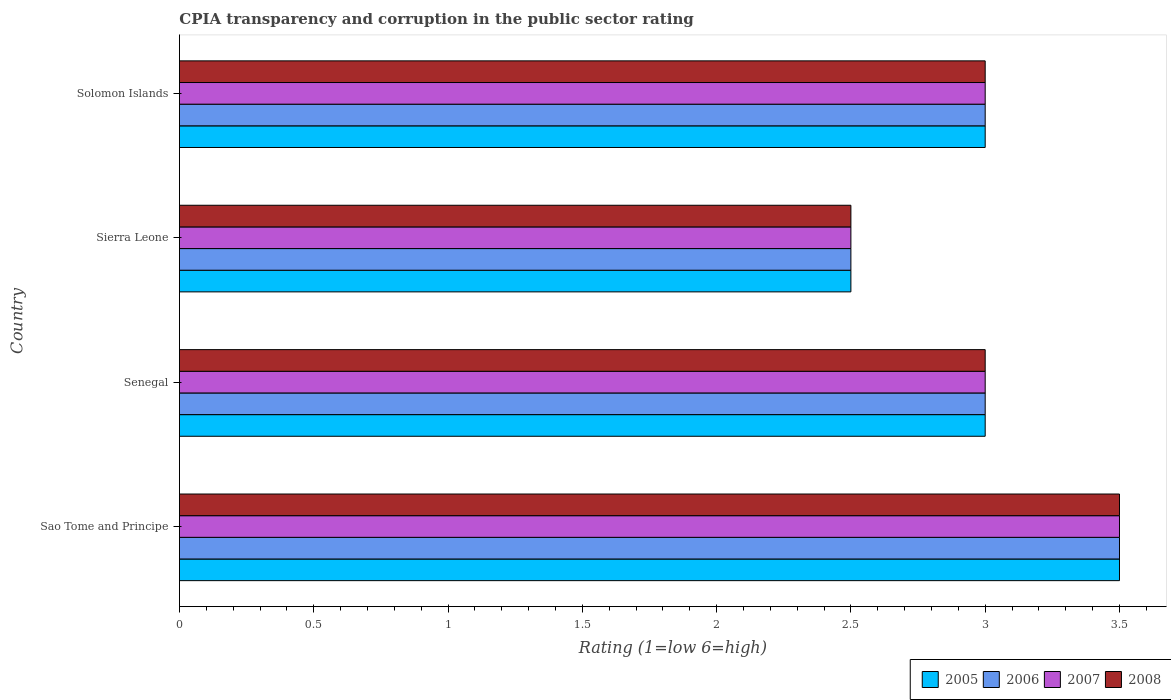How many groups of bars are there?
Offer a terse response. 4. Are the number of bars on each tick of the Y-axis equal?
Offer a terse response. Yes. How many bars are there on the 1st tick from the bottom?
Make the answer very short. 4. What is the label of the 3rd group of bars from the top?
Ensure brevity in your answer.  Senegal. What is the CPIA rating in 2006 in Senegal?
Ensure brevity in your answer.  3. Across all countries, what is the maximum CPIA rating in 2005?
Ensure brevity in your answer.  3.5. Across all countries, what is the minimum CPIA rating in 2008?
Provide a succinct answer. 2.5. In which country was the CPIA rating in 2008 maximum?
Provide a short and direct response. Sao Tome and Principe. In which country was the CPIA rating in 2007 minimum?
Offer a terse response. Sierra Leone. What is the total CPIA rating in 2005 in the graph?
Ensure brevity in your answer.  12. What is the average CPIA rating in 2007 per country?
Provide a short and direct response. 3. What is the difference between the CPIA rating in 2007 and CPIA rating in 2005 in Sao Tome and Principe?
Ensure brevity in your answer.  0. In how many countries, is the CPIA rating in 2005 greater than 3 ?
Your answer should be compact. 1. What is the ratio of the CPIA rating in 2006 in Sao Tome and Principe to that in Solomon Islands?
Keep it short and to the point. 1.17. Is the CPIA rating in 2007 in Senegal less than that in Sierra Leone?
Provide a succinct answer. No. What is the difference between the highest and the second highest CPIA rating in 2006?
Give a very brief answer. 0.5. What is the difference between the highest and the lowest CPIA rating in 2005?
Provide a succinct answer. 1. Is the sum of the CPIA rating in 2006 in Sao Tome and Principe and Solomon Islands greater than the maximum CPIA rating in 2008 across all countries?
Ensure brevity in your answer.  Yes. Is it the case that in every country, the sum of the CPIA rating in 2007 and CPIA rating in 2006 is greater than the sum of CPIA rating in 2008 and CPIA rating in 2005?
Your response must be concise. No. What does the 4th bar from the top in Solomon Islands represents?
Your answer should be compact. 2005. What does the 3rd bar from the bottom in Solomon Islands represents?
Keep it short and to the point. 2007. Are all the bars in the graph horizontal?
Keep it short and to the point. Yes. What is the difference between two consecutive major ticks on the X-axis?
Offer a very short reply. 0.5. Does the graph contain any zero values?
Ensure brevity in your answer.  No. Where does the legend appear in the graph?
Give a very brief answer. Bottom right. What is the title of the graph?
Ensure brevity in your answer.  CPIA transparency and corruption in the public sector rating. What is the Rating (1=low 6=high) of 2005 in Sao Tome and Principe?
Provide a short and direct response. 3.5. What is the Rating (1=low 6=high) of 2006 in Sao Tome and Principe?
Provide a short and direct response. 3.5. What is the Rating (1=low 6=high) in 2005 in Senegal?
Your answer should be compact. 3. What is the Rating (1=low 6=high) of 2006 in Senegal?
Offer a terse response. 3. What is the Rating (1=low 6=high) in 2007 in Senegal?
Provide a short and direct response. 3. What is the Rating (1=low 6=high) in 2007 in Sierra Leone?
Make the answer very short. 2.5. What is the Rating (1=low 6=high) in 2008 in Sierra Leone?
Offer a terse response. 2.5. What is the Rating (1=low 6=high) in 2007 in Solomon Islands?
Give a very brief answer. 3. Across all countries, what is the maximum Rating (1=low 6=high) of 2005?
Your answer should be very brief. 3.5. Across all countries, what is the maximum Rating (1=low 6=high) of 2007?
Offer a terse response. 3.5. Across all countries, what is the maximum Rating (1=low 6=high) of 2008?
Your answer should be compact. 3.5. Across all countries, what is the minimum Rating (1=low 6=high) in 2005?
Offer a very short reply. 2.5. What is the total Rating (1=low 6=high) of 2007 in the graph?
Give a very brief answer. 12. What is the difference between the Rating (1=low 6=high) in 2007 in Sao Tome and Principe and that in Senegal?
Keep it short and to the point. 0.5. What is the difference between the Rating (1=low 6=high) in 2005 in Sao Tome and Principe and that in Sierra Leone?
Provide a short and direct response. 1. What is the difference between the Rating (1=low 6=high) of 2008 in Sao Tome and Principe and that in Sierra Leone?
Your answer should be very brief. 1. What is the difference between the Rating (1=low 6=high) in 2007 in Sao Tome and Principe and that in Solomon Islands?
Your response must be concise. 0.5. What is the difference between the Rating (1=low 6=high) of 2008 in Sao Tome and Principe and that in Solomon Islands?
Provide a succinct answer. 0.5. What is the difference between the Rating (1=low 6=high) in 2005 in Senegal and that in Sierra Leone?
Offer a terse response. 0.5. What is the difference between the Rating (1=low 6=high) of 2006 in Senegal and that in Sierra Leone?
Ensure brevity in your answer.  0.5. What is the difference between the Rating (1=low 6=high) of 2007 in Senegal and that in Sierra Leone?
Give a very brief answer. 0.5. What is the difference between the Rating (1=low 6=high) in 2008 in Senegal and that in Sierra Leone?
Ensure brevity in your answer.  0.5. What is the difference between the Rating (1=low 6=high) of 2006 in Senegal and that in Solomon Islands?
Make the answer very short. 0. What is the difference between the Rating (1=low 6=high) of 2006 in Sierra Leone and that in Solomon Islands?
Offer a terse response. -0.5. What is the difference between the Rating (1=low 6=high) of 2008 in Sierra Leone and that in Solomon Islands?
Your answer should be compact. -0.5. What is the difference between the Rating (1=low 6=high) in 2005 in Sao Tome and Principe and the Rating (1=low 6=high) in 2007 in Senegal?
Your response must be concise. 0.5. What is the difference between the Rating (1=low 6=high) in 2005 in Sao Tome and Principe and the Rating (1=low 6=high) in 2008 in Senegal?
Make the answer very short. 0.5. What is the difference between the Rating (1=low 6=high) in 2006 in Sao Tome and Principe and the Rating (1=low 6=high) in 2007 in Senegal?
Keep it short and to the point. 0.5. What is the difference between the Rating (1=low 6=high) in 2006 in Sao Tome and Principe and the Rating (1=low 6=high) in 2008 in Senegal?
Provide a succinct answer. 0.5. What is the difference between the Rating (1=low 6=high) of 2005 in Sao Tome and Principe and the Rating (1=low 6=high) of 2007 in Sierra Leone?
Provide a short and direct response. 1. What is the difference between the Rating (1=low 6=high) of 2005 in Sao Tome and Principe and the Rating (1=low 6=high) of 2008 in Sierra Leone?
Your response must be concise. 1. What is the difference between the Rating (1=low 6=high) in 2006 in Sao Tome and Principe and the Rating (1=low 6=high) in 2008 in Solomon Islands?
Offer a terse response. 0.5. What is the difference between the Rating (1=low 6=high) of 2005 in Senegal and the Rating (1=low 6=high) of 2007 in Sierra Leone?
Your answer should be compact. 0.5. What is the difference between the Rating (1=low 6=high) of 2006 in Senegal and the Rating (1=low 6=high) of 2007 in Sierra Leone?
Give a very brief answer. 0.5. What is the difference between the Rating (1=low 6=high) in 2006 in Senegal and the Rating (1=low 6=high) in 2008 in Sierra Leone?
Your answer should be compact. 0.5. What is the difference between the Rating (1=low 6=high) of 2007 in Senegal and the Rating (1=low 6=high) of 2008 in Sierra Leone?
Offer a very short reply. 0.5. What is the difference between the Rating (1=low 6=high) in 2006 in Senegal and the Rating (1=low 6=high) in 2008 in Solomon Islands?
Provide a short and direct response. 0. What is the difference between the Rating (1=low 6=high) in 2005 in Sierra Leone and the Rating (1=low 6=high) in 2006 in Solomon Islands?
Offer a terse response. -0.5. What is the difference between the Rating (1=low 6=high) of 2005 in Sierra Leone and the Rating (1=low 6=high) of 2007 in Solomon Islands?
Ensure brevity in your answer.  -0.5. What is the difference between the Rating (1=low 6=high) of 2005 in Sierra Leone and the Rating (1=low 6=high) of 2008 in Solomon Islands?
Provide a succinct answer. -0.5. What is the difference between the Rating (1=low 6=high) in 2006 in Sierra Leone and the Rating (1=low 6=high) in 2008 in Solomon Islands?
Your response must be concise. -0.5. What is the difference between the Rating (1=low 6=high) of 2007 in Sierra Leone and the Rating (1=low 6=high) of 2008 in Solomon Islands?
Provide a short and direct response. -0.5. What is the average Rating (1=low 6=high) in 2007 per country?
Keep it short and to the point. 3. What is the difference between the Rating (1=low 6=high) in 2005 and Rating (1=low 6=high) in 2006 in Sao Tome and Principe?
Offer a very short reply. 0. What is the difference between the Rating (1=low 6=high) in 2005 and Rating (1=low 6=high) in 2008 in Sao Tome and Principe?
Give a very brief answer. 0. What is the difference between the Rating (1=low 6=high) of 2006 and Rating (1=low 6=high) of 2007 in Sao Tome and Principe?
Give a very brief answer. 0. What is the difference between the Rating (1=low 6=high) in 2006 and Rating (1=low 6=high) in 2008 in Sao Tome and Principe?
Your answer should be very brief. 0. What is the difference between the Rating (1=low 6=high) of 2006 and Rating (1=low 6=high) of 2007 in Senegal?
Give a very brief answer. 0. What is the difference between the Rating (1=low 6=high) in 2006 and Rating (1=low 6=high) in 2008 in Senegal?
Offer a terse response. 0. What is the difference between the Rating (1=low 6=high) in 2005 and Rating (1=low 6=high) in 2006 in Sierra Leone?
Your answer should be compact. 0. What is the difference between the Rating (1=low 6=high) of 2005 and Rating (1=low 6=high) of 2007 in Sierra Leone?
Your answer should be compact. 0. What is the difference between the Rating (1=low 6=high) of 2005 and Rating (1=low 6=high) of 2008 in Sierra Leone?
Provide a short and direct response. 0. What is the difference between the Rating (1=low 6=high) of 2006 and Rating (1=low 6=high) of 2008 in Sierra Leone?
Give a very brief answer. 0. What is the difference between the Rating (1=low 6=high) in 2007 and Rating (1=low 6=high) in 2008 in Sierra Leone?
Ensure brevity in your answer.  0. What is the difference between the Rating (1=low 6=high) of 2005 and Rating (1=low 6=high) of 2006 in Solomon Islands?
Keep it short and to the point. 0. What is the difference between the Rating (1=low 6=high) in 2006 and Rating (1=low 6=high) in 2008 in Solomon Islands?
Give a very brief answer. 0. What is the ratio of the Rating (1=low 6=high) of 2005 in Sao Tome and Principe to that in Senegal?
Your answer should be very brief. 1.17. What is the ratio of the Rating (1=low 6=high) of 2008 in Sao Tome and Principe to that in Senegal?
Give a very brief answer. 1.17. What is the ratio of the Rating (1=low 6=high) of 2005 in Sao Tome and Principe to that in Sierra Leone?
Provide a short and direct response. 1.4. What is the ratio of the Rating (1=low 6=high) of 2006 in Sao Tome and Principe to that in Sierra Leone?
Offer a terse response. 1.4. What is the ratio of the Rating (1=low 6=high) of 2007 in Sao Tome and Principe to that in Sierra Leone?
Provide a succinct answer. 1.4. What is the ratio of the Rating (1=low 6=high) in 2008 in Sao Tome and Principe to that in Sierra Leone?
Your response must be concise. 1.4. What is the ratio of the Rating (1=low 6=high) in 2007 in Sao Tome and Principe to that in Solomon Islands?
Ensure brevity in your answer.  1.17. What is the ratio of the Rating (1=low 6=high) in 2008 in Sao Tome and Principe to that in Solomon Islands?
Provide a short and direct response. 1.17. What is the ratio of the Rating (1=low 6=high) of 2005 in Senegal to that in Sierra Leone?
Provide a succinct answer. 1.2. What is the ratio of the Rating (1=low 6=high) of 2008 in Senegal to that in Sierra Leone?
Provide a short and direct response. 1.2. What is the ratio of the Rating (1=low 6=high) of 2005 in Senegal to that in Solomon Islands?
Keep it short and to the point. 1. What is the ratio of the Rating (1=low 6=high) in 2006 in Senegal to that in Solomon Islands?
Provide a succinct answer. 1. What is the ratio of the Rating (1=low 6=high) of 2007 in Senegal to that in Solomon Islands?
Your answer should be very brief. 1. What is the ratio of the Rating (1=low 6=high) in 2008 in Senegal to that in Solomon Islands?
Your answer should be very brief. 1. What is the ratio of the Rating (1=low 6=high) of 2008 in Sierra Leone to that in Solomon Islands?
Make the answer very short. 0.83. What is the difference between the highest and the second highest Rating (1=low 6=high) of 2005?
Give a very brief answer. 0.5. What is the difference between the highest and the second highest Rating (1=low 6=high) of 2007?
Make the answer very short. 0.5. What is the difference between the highest and the second highest Rating (1=low 6=high) in 2008?
Your answer should be very brief. 0.5. What is the difference between the highest and the lowest Rating (1=low 6=high) of 2007?
Provide a succinct answer. 1. 